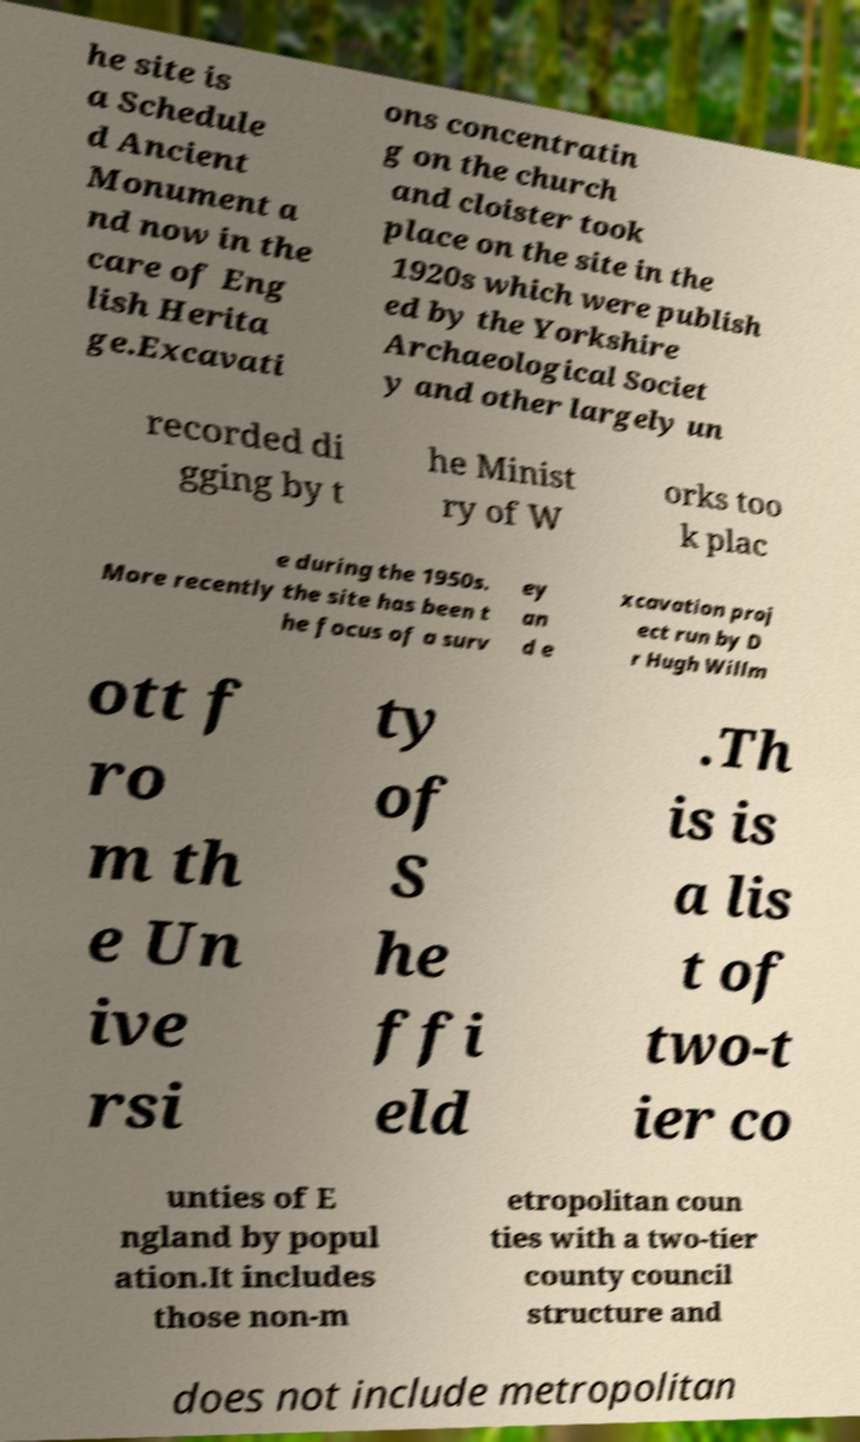Can you read and provide the text displayed in the image?This photo seems to have some interesting text. Can you extract and type it out for me? he site is a Schedule d Ancient Monument a nd now in the care of Eng lish Herita ge.Excavati ons concentratin g on the church and cloister took place on the site in the 1920s which were publish ed by the Yorkshire Archaeological Societ y and other largely un recorded di gging by t he Minist ry of W orks too k plac e during the 1950s. More recently the site has been t he focus of a surv ey an d e xcavation proj ect run by D r Hugh Willm ott f ro m th e Un ive rsi ty of S he ffi eld .Th is is a lis t of two-t ier co unties of E ngland by popul ation.It includes those non-m etropolitan coun ties with a two-tier county council structure and does not include metropolitan 